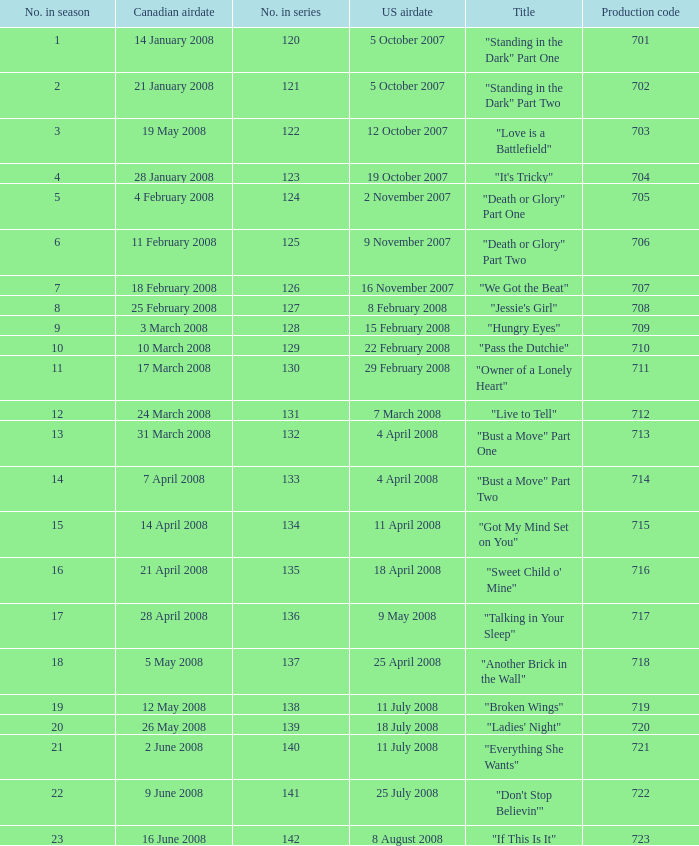The canadian airdate of 17 march 2008 had how many numbers in the season? 1.0. 